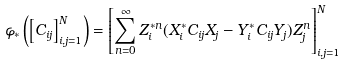Convert formula to latex. <formula><loc_0><loc_0><loc_500><loc_500>\varphi _ { * } \left ( \left [ C _ { i j } \right ] _ { i , j = 1 } ^ { N } \right ) = \left [ \sum _ { n = 0 } ^ { \infty } Z _ { i } ^ { * n } ( X _ { i } ^ { * } C _ { i j } X _ { j } - Y _ { i } ^ { * } C _ { i j } Y _ { j } ) Z _ { j } ^ { n } \right ] _ { i , j = 1 } ^ { N }</formula> 